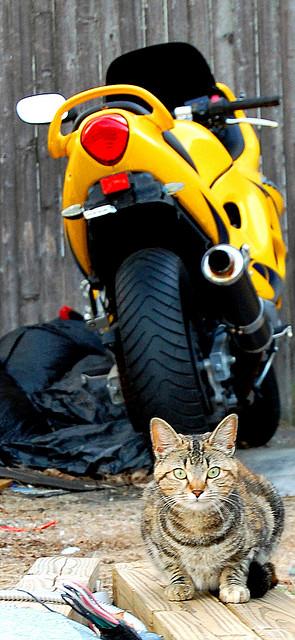Is this cat paying attention to the camera?
Answer briefly. Yes. What is behind the cat?
Keep it brief. Motorcycle. How old is this cat?
Write a very short answer. 2. 